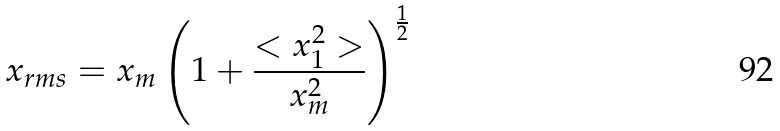Convert formula to latex. <formula><loc_0><loc_0><loc_500><loc_500>x _ { r m s } = x _ { m } \left ( 1 + \frac { < x _ { 1 } ^ { 2 } > } { x _ { m } ^ { 2 } } \right ) ^ { \frac { 1 } { 2 } }</formula> 